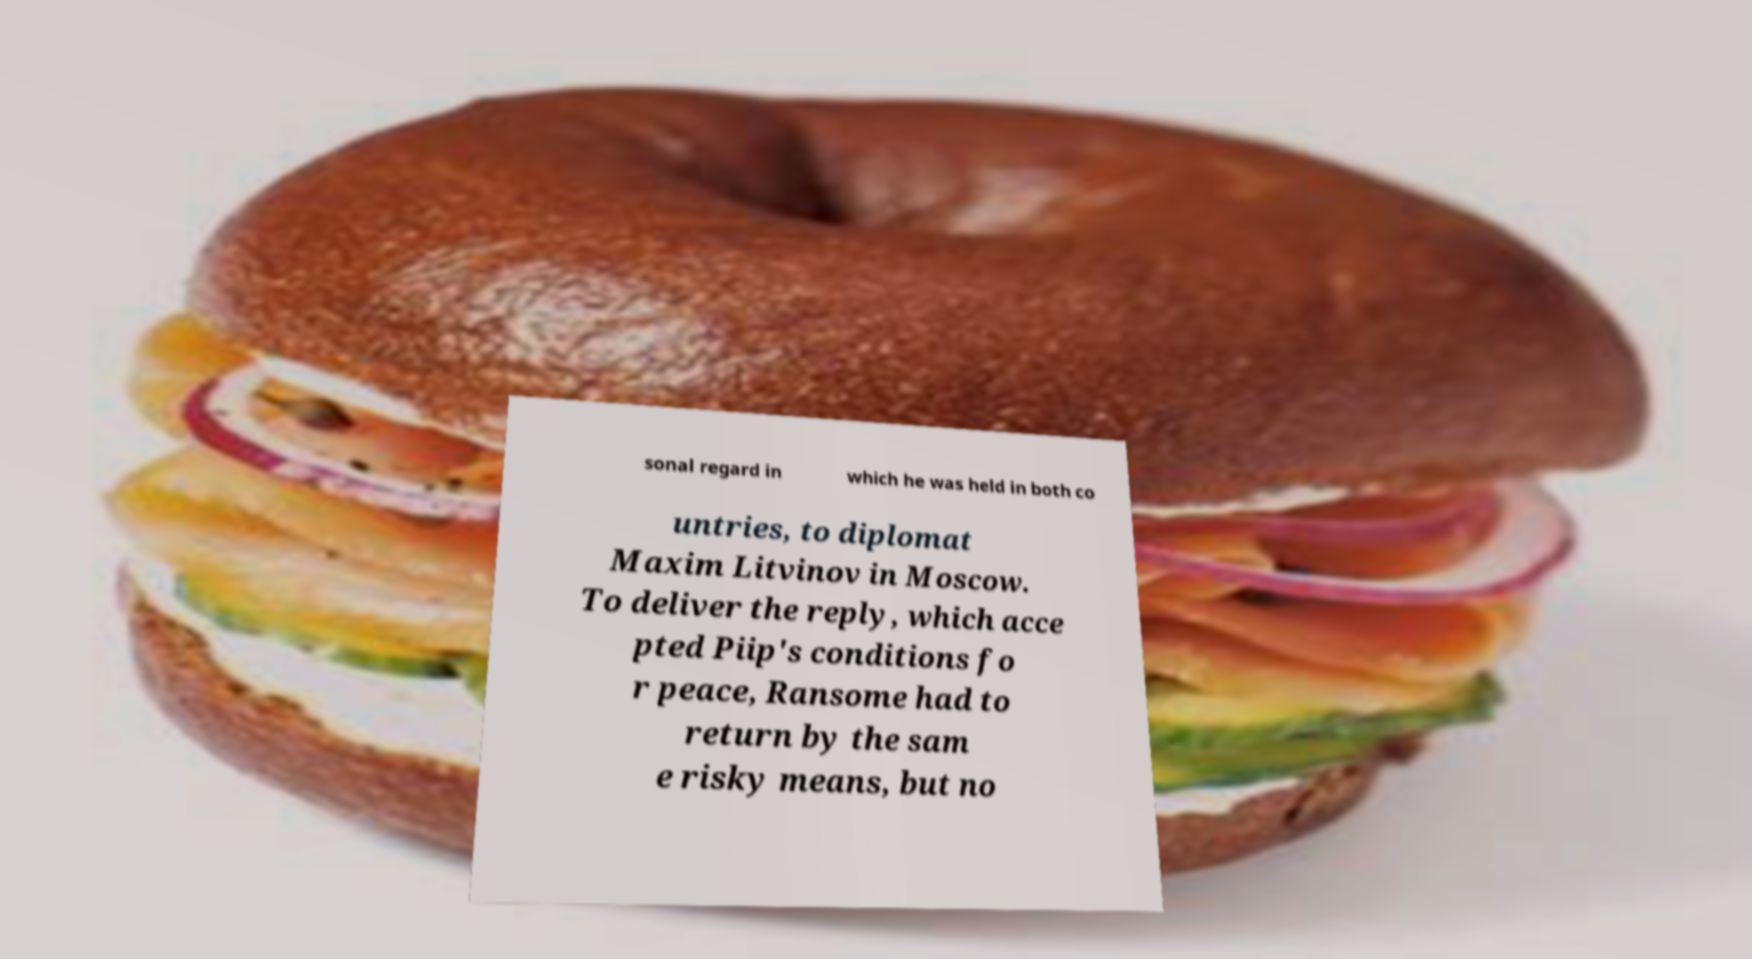Please identify and transcribe the text found in this image. sonal regard in which he was held in both co untries, to diplomat Maxim Litvinov in Moscow. To deliver the reply, which acce pted Piip's conditions fo r peace, Ransome had to return by the sam e risky means, but no 